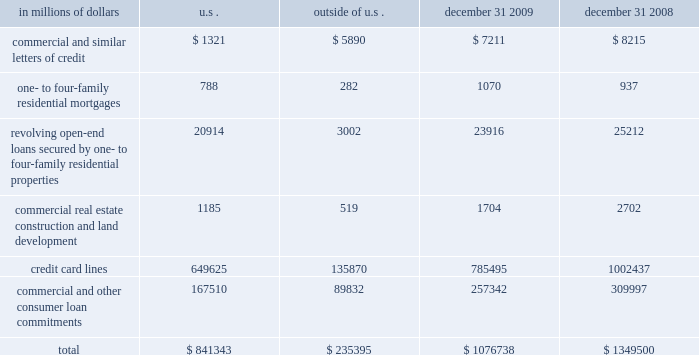Credit commitments and lines of credit the table below summarizes citigroup 2019s credit commitments as of december 31 , 2009 and december 31 , 2008 : in millions of dollars u.s .
Outside of december 31 , december 31 .
The majority of unused commitments are contingent upon customers 2019 maintaining specific credit standards .
Commercial commitments generally have floating interest rates and fixed expiration dates and may require payment of fees .
Such fees ( net of certain direct costs ) are deferred and , upon exercise of the commitment , amortized over the life of the loan or , if exercise is deemed remote , amortized over the commitment period .
Commercial and similar letters of credit a commercial letter of credit is an instrument by which citigroup substitutes its credit for that of a customer to enable the customer to finance the purchase of goods or to incur other commitments .
Citigroup issues a letter on behalf of its client to a supplier and agrees to pay the supplier upon presentation of documentary evidence that the supplier has performed in accordance with the terms of the letter of credit .
When a letter of credit is drawn , the customer is then required to reimburse citigroup .
One- to four-family residential mortgages a one- to four-family residential mortgage commitment is a written confirmation from citigroup to a seller of a property that the bank will advance the specified sums enabling the buyer to complete the purchase .
Revolving open-end loans secured by one- to four-family residential properties revolving open-end loans secured by one- to four-family residential properties are essentially home equity lines of credit .
A home equity line of credit is a loan secured by a primary residence or second home to the extent of the excess of fair market value over the debt outstanding for the first mortgage .
Commercial real estate , construction and land development commercial real estate , construction and land development include unused portions of commitments to extend credit for the purpose of financing commercial and multifamily residential properties as well as land development projects .
Both secured-by-real-estate and unsecured commitments are included in this line , as well as undistributed loan proceeds , where there is an obligation to advance for construction progress payments .
However , this line only includes those extensions of credit that , once funded , will be classified as total loans , net on the consolidated balance sheet .
Credit card lines citigroup provides credit to customers by issuing credit cards .
The credit card lines are unconditionally cancellable by the issuer .
Commercial and other consumer loan commitments commercial and other consumer loan commitments include overdraft and liquidity facilities , as well as commercial commitments to make or purchase loans , to purchase third-party receivables , to provide note issuance or revolving underwriting facilities and to invest in the form of equity .
Amounts include $ 126 billion and $ 170 billion with an original maturity of less than one year at december 31 , 2009 and december 31 , 2008 , respectively .
In addition , included in this line item are highly leveraged financing commitments , which are agreements that provide funding to a borrower with higher levels of debt ( measured by the ratio of debt capital to equity capital of the borrower ) than is generally considered normal for other companies .
This type of financing is commonly employed in corporate acquisitions , management buy-outs and similar transactions. .
What percentage of one- to four-family residential mortgages as of december 31 , 2009 are outside the u.s.? 
Computations: (282 / 1070)
Answer: 0.26355. Credit commitments and lines of credit the table below summarizes citigroup 2019s credit commitments as of december 31 , 2009 and december 31 , 2008 : in millions of dollars u.s .
Outside of december 31 , december 31 .
The majority of unused commitments are contingent upon customers 2019 maintaining specific credit standards .
Commercial commitments generally have floating interest rates and fixed expiration dates and may require payment of fees .
Such fees ( net of certain direct costs ) are deferred and , upon exercise of the commitment , amortized over the life of the loan or , if exercise is deemed remote , amortized over the commitment period .
Commercial and similar letters of credit a commercial letter of credit is an instrument by which citigroup substitutes its credit for that of a customer to enable the customer to finance the purchase of goods or to incur other commitments .
Citigroup issues a letter on behalf of its client to a supplier and agrees to pay the supplier upon presentation of documentary evidence that the supplier has performed in accordance with the terms of the letter of credit .
When a letter of credit is drawn , the customer is then required to reimburse citigroup .
One- to four-family residential mortgages a one- to four-family residential mortgage commitment is a written confirmation from citigroup to a seller of a property that the bank will advance the specified sums enabling the buyer to complete the purchase .
Revolving open-end loans secured by one- to four-family residential properties revolving open-end loans secured by one- to four-family residential properties are essentially home equity lines of credit .
A home equity line of credit is a loan secured by a primary residence or second home to the extent of the excess of fair market value over the debt outstanding for the first mortgage .
Commercial real estate , construction and land development commercial real estate , construction and land development include unused portions of commitments to extend credit for the purpose of financing commercial and multifamily residential properties as well as land development projects .
Both secured-by-real-estate and unsecured commitments are included in this line , as well as undistributed loan proceeds , where there is an obligation to advance for construction progress payments .
However , this line only includes those extensions of credit that , once funded , will be classified as total loans , net on the consolidated balance sheet .
Credit card lines citigroup provides credit to customers by issuing credit cards .
The credit card lines are unconditionally cancellable by the issuer .
Commercial and other consumer loan commitments commercial and other consumer loan commitments include overdraft and liquidity facilities , as well as commercial commitments to make or purchase loans , to purchase third-party receivables , to provide note issuance or revolving underwriting facilities and to invest in the form of equity .
Amounts include $ 126 billion and $ 170 billion with an original maturity of less than one year at december 31 , 2009 and december 31 , 2008 , respectively .
In addition , included in this line item are highly leveraged financing commitments , which are agreements that provide funding to a borrower with higher levels of debt ( measured by the ratio of debt capital to equity capital of the borrower ) than is generally considered normal for other companies .
This type of financing is commonly employed in corporate acquisitions , management buy-outs and similar transactions. .
What percentage of total credit commitments as of december 31 , 2009 are outside the u.s.? 
Computations: (235395 / 1076738)
Answer: 0.21862. Credit commitments and lines of credit the table below summarizes citigroup 2019s credit commitments as of december 31 , 2009 and december 31 , 2008 : in millions of dollars u.s .
Outside of december 31 , december 31 .
The majority of unused commitments are contingent upon customers 2019 maintaining specific credit standards .
Commercial commitments generally have floating interest rates and fixed expiration dates and may require payment of fees .
Such fees ( net of certain direct costs ) are deferred and , upon exercise of the commitment , amortized over the life of the loan or , if exercise is deemed remote , amortized over the commitment period .
Commercial and similar letters of credit a commercial letter of credit is an instrument by which citigroup substitutes its credit for that of a customer to enable the customer to finance the purchase of goods or to incur other commitments .
Citigroup issues a letter on behalf of its client to a supplier and agrees to pay the supplier upon presentation of documentary evidence that the supplier has performed in accordance with the terms of the letter of credit .
When a letter of credit is drawn , the customer is then required to reimburse citigroup .
One- to four-family residential mortgages a one- to four-family residential mortgage commitment is a written confirmation from citigroup to a seller of a property that the bank will advance the specified sums enabling the buyer to complete the purchase .
Revolving open-end loans secured by one- to four-family residential properties revolving open-end loans secured by one- to four-family residential properties are essentially home equity lines of credit .
A home equity line of credit is a loan secured by a primary residence or second home to the extent of the excess of fair market value over the debt outstanding for the first mortgage .
Commercial real estate , construction and land development commercial real estate , construction and land development include unused portions of commitments to extend credit for the purpose of financing commercial and multifamily residential properties as well as land development projects .
Both secured-by-real-estate and unsecured commitments are included in this line , as well as undistributed loan proceeds , where there is an obligation to advance for construction progress payments .
However , this line only includes those extensions of credit that , once funded , will be classified as total loans , net on the consolidated balance sheet .
Credit card lines citigroup provides credit to customers by issuing credit cards .
The credit card lines are unconditionally cancellable by the issuer .
Commercial and other consumer loan commitments commercial and other consumer loan commitments include overdraft and liquidity facilities , as well as commercial commitments to make or purchase loans , to purchase third-party receivables , to provide note issuance or revolving underwriting facilities and to invest in the form of equity .
Amounts include $ 126 billion and $ 170 billion with an original maturity of less than one year at december 31 , 2009 and december 31 , 2008 , respectively .
In addition , included in this line item are highly leveraged financing commitments , which are agreements that provide funding to a borrower with higher levels of debt ( measured by the ratio of debt capital to equity capital of the borrower ) than is generally considered normal for other companies .
This type of financing is commonly employed in corporate acquisitions , management buy-outs and similar transactions. .
What was the percentage decrease the credit card lines from 2008 to 2009? 
Computations: ((785495 - 1002437) / 1002437)
Answer: -0.21641. 